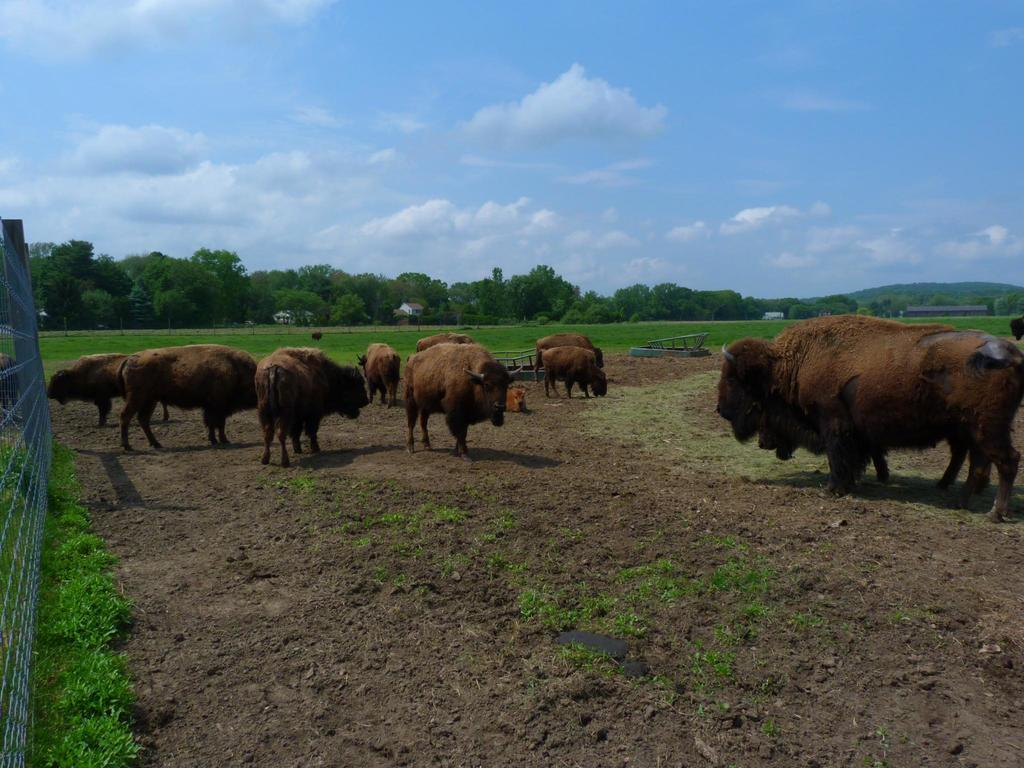What animals are on the floor in the image? There are yaks on the floor in the image. What type of vegetation can be seen in the image? There are plants and trees in the image. What architectural feature is present in the image? There is a fencing in the image. Can you tell me how many holes are visible in the image? There is no mention of any holes in the image, so it is not possible to determine their number. 